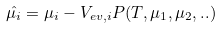<formula> <loc_0><loc_0><loc_500><loc_500>\hat { \mu _ { i } } = \mu _ { i } - V _ { e v , i } P ( T , \mu _ { 1 } , \mu _ { 2 } , . . )</formula> 